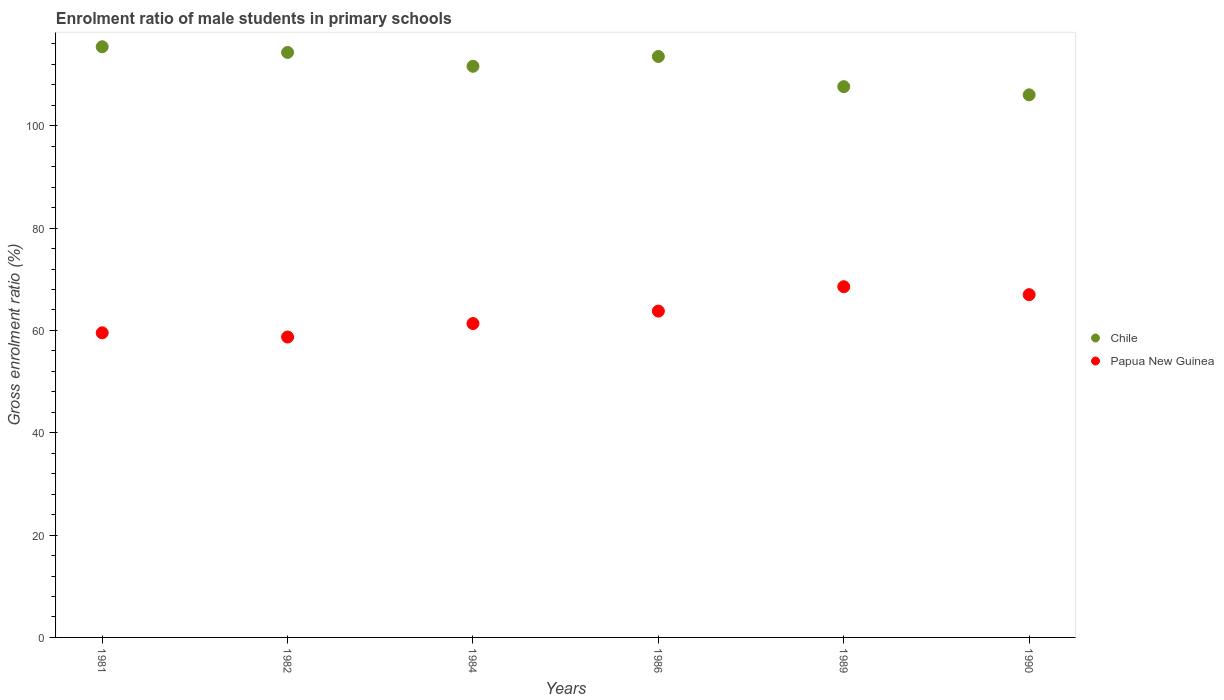What is the enrolment ratio of male students in primary schools in Chile in 1984?
Provide a succinct answer. 111.62. Across all years, what is the maximum enrolment ratio of male students in primary schools in Papua New Guinea?
Provide a short and direct response. 68.54. Across all years, what is the minimum enrolment ratio of male students in primary schools in Chile?
Your answer should be compact. 106.04. What is the total enrolment ratio of male students in primary schools in Chile in the graph?
Your answer should be very brief. 668.6. What is the difference between the enrolment ratio of male students in primary schools in Chile in 1989 and that in 1990?
Keep it short and to the point. 1.6. What is the difference between the enrolment ratio of male students in primary schools in Papua New Guinea in 1981 and the enrolment ratio of male students in primary schools in Chile in 1986?
Provide a short and direct response. -54. What is the average enrolment ratio of male students in primary schools in Papua New Guinea per year?
Keep it short and to the point. 63.15. In the year 1989, what is the difference between the enrolment ratio of male students in primary schools in Chile and enrolment ratio of male students in primary schools in Papua New Guinea?
Keep it short and to the point. 39.1. What is the ratio of the enrolment ratio of male students in primary schools in Papua New Guinea in 1981 to that in 1989?
Your response must be concise. 0.87. Is the enrolment ratio of male students in primary schools in Chile in 1981 less than that in 1989?
Offer a terse response. No. Is the difference between the enrolment ratio of male students in primary schools in Chile in 1984 and 1986 greater than the difference between the enrolment ratio of male students in primary schools in Papua New Guinea in 1984 and 1986?
Your response must be concise. Yes. What is the difference between the highest and the second highest enrolment ratio of male students in primary schools in Papua New Guinea?
Keep it short and to the point. 1.55. What is the difference between the highest and the lowest enrolment ratio of male students in primary schools in Papua New Guinea?
Offer a terse response. 9.83. In how many years, is the enrolment ratio of male students in primary schools in Chile greater than the average enrolment ratio of male students in primary schools in Chile taken over all years?
Keep it short and to the point. 4. Is the sum of the enrolment ratio of male students in primary schools in Chile in 1982 and 1984 greater than the maximum enrolment ratio of male students in primary schools in Papua New Guinea across all years?
Your response must be concise. Yes. Is the enrolment ratio of male students in primary schools in Papua New Guinea strictly less than the enrolment ratio of male students in primary schools in Chile over the years?
Provide a short and direct response. Yes. How many dotlines are there?
Ensure brevity in your answer.  2. What is the difference between two consecutive major ticks on the Y-axis?
Offer a terse response. 20. Are the values on the major ticks of Y-axis written in scientific E-notation?
Your response must be concise. No. Does the graph contain grids?
Ensure brevity in your answer.  No. How many legend labels are there?
Provide a succinct answer. 2. What is the title of the graph?
Your answer should be compact. Enrolment ratio of male students in primary schools. Does "Bahrain" appear as one of the legend labels in the graph?
Offer a terse response. No. What is the label or title of the X-axis?
Provide a succinct answer. Years. What is the Gross enrolment ratio (%) of Chile in 1981?
Your answer should be compact. 115.44. What is the Gross enrolment ratio (%) in Papua New Guinea in 1981?
Make the answer very short. 59.53. What is the Gross enrolment ratio (%) in Chile in 1982?
Offer a very short reply. 114.33. What is the Gross enrolment ratio (%) in Papua New Guinea in 1982?
Provide a short and direct response. 58.71. What is the Gross enrolment ratio (%) of Chile in 1984?
Offer a terse response. 111.62. What is the Gross enrolment ratio (%) in Papua New Guinea in 1984?
Ensure brevity in your answer.  61.34. What is the Gross enrolment ratio (%) of Chile in 1986?
Make the answer very short. 113.53. What is the Gross enrolment ratio (%) in Papua New Guinea in 1986?
Your answer should be very brief. 63.77. What is the Gross enrolment ratio (%) in Chile in 1989?
Offer a very short reply. 107.64. What is the Gross enrolment ratio (%) of Papua New Guinea in 1989?
Provide a short and direct response. 68.54. What is the Gross enrolment ratio (%) of Chile in 1990?
Make the answer very short. 106.04. What is the Gross enrolment ratio (%) in Papua New Guinea in 1990?
Keep it short and to the point. 66.99. Across all years, what is the maximum Gross enrolment ratio (%) of Chile?
Make the answer very short. 115.44. Across all years, what is the maximum Gross enrolment ratio (%) of Papua New Guinea?
Your answer should be very brief. 68.54. Across all years, what is the minimum Gross enrolment ratio (%) in Chile?
Provide a short and direct response. 106.04. Across all years, what is the minimum Gross enrolment ratio (%) of Papua New Guinea?
Make the answer very short. 58.71. What is the total Gross enrolment ratio (%) in Chile in the graph?
Offer a very short reply. 668.6. What is the total Gross enrolment ratio (%) in Papua New Guinea in the graph?
Offer a very short reply. 378.89. What is the difference between the Gross enrolment ratio (%) of Chile in 1981 and that in 1982?
Ensure brevity in your answer.  1.11. What is the difference between the Gross enrolment ratio (%) of Papua New Guinea in 1981 and that in 1982?
Your response must be concise. 0.82. What is the difference between the Gross enrolment ratio (%) in Chile in 1981 and that in 1984?
Provide a succinct answer. 3.82. What is the difference between the Gross enrolment ratio (%) in Papua New Guinea in 1981 and that in 1984?
Ensure brevity in your answer.  -1.81. What is the difference between the Gross enrolment ratio (%) of Chile in 1981 and that in 1986?
Provide a succinct answer. 1.9. What is the difference between the Gross enrolment ratio (%) of Papua New Guinea in 1981 and that in 1986?
Your response must be concise. -4.24. What is the difference between the Gross enrolment ratio (%) of Chile in 1981 and that in 1989?
Make the answer very short. 7.8. What is the difference between the Gross enrolment ratio (%) of Papua New Guinea in 1981 and that in 1989?
Make the answer very short. -9.01. What is the difference between the Gross enrolment ratio (%) in Chile in 1981 and that in 1990?
Keep it short and to the point. 9.39. What is the difference between the Gross enrolment ratio (%) of Papua New Guinea in 1981 and that in 1990?
Make the answer very short. -7.46. What is the difference between the Gross enrolment ratio (%) of Chile in 1982 and that in 1984?
Provide a succinct answer. 2.71. What is the difference between the Gross enrolment ratio (%) in Papua New Guinea in 1982 and that in 1984?
Keep it short and to the point. -2.63. What is the difference between the Gross enrolment ratio (%) in Chile in 1982 and that in 1986?
Provide a short and direct response. 0.79. What is the difference between the Gross enrolment ratio (%) of Papua New Guinea in 1982 and that in 1986?
Provide a succinct answer. -5.06. What is the difference between the Gross enrolment ratio (%) in Chile in 1982 and that in 1989?
Your answer should be compact. 6.69. What is the difference between the Gross enrolment ratio (%) of Papua New Guinea in 1982 and that in 1989?
Provide a succinct answer. -9.83. What is the difference between the Gross enrolment ratio (%) of Chile in 1982 and that in 1990?
Offer a very short reply. 8.29. What is the difference between the Gross enrolment ratio (%) in Papua New Guinea in 1982 and that in 1990?
Ensure brevity in your answer.  -8.28. What is the difference between the Gross enrolment ratio (%) of Chile in 1984 and that in 1986?
Provide a succinct answer. -1.91. What is the difference between the Gross enrolment ratio (%) of Papua New Guinea in 1984 and that in 1986?
Your answer should be compact. -2.43. What is the difference between the Gross enrolment ratio (%) of Chile in 1984 and that in 1989?
Offer a terse response. 3.98. What is the difference between the Gross enrolment ratio (%) of Papua New Guinea in 1984 and that in 1989?
Keep it short and to the point. -7.2. What is the difference between the Gross enrolment ratio (%) in Chile in 1984 and that in 1990?
Offer a terse response. 5.58. What is the difference between the Gross enrolment ratio (%) in Papua New Guinea in 1984 and that in 1990?
Give a very brief answer. -5.65. What is the difference between the Gross enrolment ratio (%) of Chile in 1986 and that in 1989?
Provide a short and direct response. 5.9. What is the difference between the Gross enrolment ratio (%) of Papua New Guinea in 1986 and that in 1989?
Give a very brief answer. -4.77. What is the difference between the Gross enrolment ratio (%) of Chile in 1986 and that in 1990?
Provide a succinct answer. 7.49. What is the difference between the Gross enrolment ratio (%) in Papua New Guinea in 1986 and that in 1990?
Offer a terse response. -3.21. What is the difference between the Gross enrolment ratio (%) in Chile in 1989 and that in 1990?
Offer a very short reply. 1.6. What is the difference between the Gross enrolment ratio (%) of Papua New Guinea in 1989 and that in 1990?
Provide a short and direct response. 1.55. What is the difference between the Gross enrolment ratio (%) of Chile in 1981 and the Gross enrolment ratio (%) of Papua New Guinea in 1982?
Your answer should be compact. 56.72. What is the difference between the Gross enrolment ratio (%) in Chile in 1981 and the Gross enrolment ratio (%) in Papua New Guinea in 1984?
Offer a very short reply. 54.09. What is the difference between the Gross enrolment ratio (%) in Chile in 1981 and the Gross enrolment ratio (%) in Papua New Guinea in 1986?
Make the answer very short. 51.66. What is the difference between the Gross enrolment ratio (%) in Chile in 1981 and the Gross enrolment ratio (%) in Papua New Guinea in 1989?
Keep it short and to the point. 46.89. What is the difference between the Gross enrolment ratio (%) in Chile in 1981 and the Gross enrolment ratio (%) in Papua New Guinea in 1990?
Make the answer very short. 48.45. What is the difference between the Gross enrolment ratio (%) in Chile in 1982 and the Gross enrolment ratio (%) in Papua New Guinea in 1984?
Your response must be concise. 52.98. What is the difference between the Gross enrolment ratio (%) in Chile in 1982 and the Gross enrolment ratio (%) in Papua New Guinea in 1986?
Provide a short and direct response. 50.55. What is the difference between the Gross enrolment ratio (%) of Chile in 1982 and the Gross enrolment ratio (%) of Papua New Guinea in 1989?
Your response must be concise. 45.79. What is the difference between the Gross enrolment ratio (%) in Chile in 1982 and the Gross enrolment ratio (%) in Papua New Guinea in 1990?
Provide a short and direct response. 47.34. What is the difference between the Gross enrolment ratio (%) in Chile in 1984 and the Gross enrolment ratio (%) in Papua New Guinea in 1986?
Your response must be concise. 47.85. What is the difference between the Gross enrolment ratio (%) of Chile in 1984 and the Gross enrolment ratio (%) of Papua New Guinea in 1989?
Offer a very short reply. 43.08. What is the difference between the Gross enrolment ratio (%) in Chile in 1984 and the Gross enrolment ratio (%) in Papua New Guinea in 1990?
Provide a short and direct response. 44.63. What is the difference between the Gross enrolment ratio (%) in Chile in 1986 and the Gross enrolment ratio (%) in Papua New Guinea in 1989?
Your response must be concise. 44.99. What is the difference between the Gross enrolment ratio (%) in Chile in 1986 and the Gross enrolment ratio (%) in Papua New Guinea in 1990?
Offer a terse response. 46.55. What is the difference between the Gross enrolment ratio (%) in Chile in 1989 and the Gross enrolment ratio (%) in Papua New Guinea in 1990?
Your answer should be compact. 40.65. What is the average Gross enrolment ratio (%) in Chile per year?
Your response must be concise. 111.43. What is the average Gross enrolment ratio (%) of Papua New Guinea per year?
Make the answer very short. 63.15. In the year 1981, what is the difference between the Gross enrolment ratio (%) of Chile and Gross enrolment ratio (%) of Papua New Guinea?
Your answer should be compact. 55.91. In the year 1982, what is the difference between the Gross enrolment ratio (%) of Chile and Gross enrolment ratio (%) of Papua New Guinea?
Offer a terse response. 55.61. In the year 1984, what is the difference between the Gross enrolment ratio (%) in Chile and Gross enrolment ratio (%) in Papua New Guinea?
Keep it short and to the point. 50.28. In the year 1986, what is the difference between the Gross enrolment ratio (%) of Chile and Gross enrolment ratio (%) of Papua New Guinea?
Make the answer very short. 49.76. In the year 1989, what is the difference between the Gross enrolment ratio (%) of Chile and Gross enrolment ratio (%) of Papua New Guinea?
Make the answer very short. 39.1. In the year 1990, what is the difference between the Gross enrolment ratio (%) in Chile and Gross enrolment ratio (%) in Papua New Guinea?
Provide a short and direct response. 39.05. What is the ratio of the Gross enrolment ratio (%) in Chile in 1981 to that in 1982?
Your response must be concise. 1.01. What is the ratio of the Gross enrolment ratio (%) in Papua New Guinea in 1981 to that in 1982?
Offer a very short reply. 1.01. What is the ratio of the Gross enrolment ratio (%) of Chile in 1981 to that in 1984?
Make the answer very short. 1.03. What is the ratio of the Gross enrolment ratio (%) of Papua New Guinea in 1981 to that in 1984?
Offer a terse response. 0.97. What is the ratio of the Gross enrolment ratio (%) of Chile in 1981 to that in 1986?
Keep it short and to the point. 1.02. What is the ratio of the Gross enrolment ratio (%) of Papua New Guinea in 1981 to that in 1986?
Provide a succinct answer. 0.93. What is the ratio of the Gross enrolment ratio (%) of Chile in 1981 to that in 1989?
Provide a short and direct response. 1.07. What is the ratio of the Gross enrolment ratio (%) of Papua New Guinea in 1981 to that in 1989?
Your answer should be compact. 0.87. What is the ratio of the Gross enrolment ratio (%) of Chile in 1981 to that in 1990?
Offer a terse response. 1.09. What is the ratio of the Gross enrolment ratio (%) in Papua New Guinea in 1981 to that in 1990?
Ensure brevity in your answer.  0.89. What is the ratio of the Gross enrolment ratio (%) in Chile in 1982 to that in 1984?
Make the answer very short. 1.02. What is the ratio of the Gross enrolment ratio (%) of Papua New Guinea in 1982 to that in 1984?
Give a very brief answer. 0.96. What is the ratio of the Gross enrolment ratio (%) of Chile in 1982 to that in 1986?
Keep it short and to the point. 1.01. What is the ratio of the Gross enrolment ratio (%) in Papua New Guinea in 1982 to that in 1986?
Give a very brief answer. 0.92. What is the ratio of the Gross enrolment ratio (%) in Chile in 1982 to that in 1989?
Your answer should be very brief. 1.06. What is the ratio of the Gross enrolment ratio (%) in Papua New Guinea in 1982 to that in 1989?
Your answer should be compact. 0.86. What is the ratio of the Gross enrolment ratio (%) of Chile in 1982 to that in 1990?
Keep it short and to the point. 1.08. What is the ratio of the Gross enrolment ratio (%) of Papua New Guinea in 1982 to that in 1990?
Give a very brief answer. 0.88. What is the ratio of the Gross enrolment ratio (%) of Chile in 1984 to that in 1986?
Your answer should be very brief. 0.98. What is the ratio of the Gross enrolment ratio (%) in Papua New Guinea in 1984 to that in 1986?
Keep it short and to the point. 0.96. What is the ratio of the Gross enrolment ratio (%) in Papua New Guinea in 1984 to that in 1989?
Offer a very short reply. 0.9. What is the ratio of the Gross enrolment ratio (%) in Chile in 1984 to that in 1990?
Make the answer very short. 1.05. What is the ratio of the Gross enrolment ratio (%) in Papua New Guinea in 1984 to that in 1990?
Your answer should be very brief. 0.92. What is the ratio of the Gross enrolment ratio (%) of Chile in 1986 to that in 1989?
Give a very brief answer. 1.05. What is the ratio of the Gross enrolment ratio (%) in Papua New Guinea in 1986 to that in 1989?
Offer a terse response. 0.93. What is the ratio of the Gross enrolment ratio (%) in Chile in 1986 to that in 1990?
Provide a short and direct response. 1.07. What is the ratio of the Gross enrolment ratio (%) of Chile in 1989 to that in 1990?
Your response must be concise. 1.02. What is the ratio of the Gross enrolment ratio (%) of Papua New Guinea in 1989 to that in 1990?
Provide a succinct answer. 1.02. What is the difference between the highest and the second highest Gross enrolment ratio (%) of Chile?
Offer a very short reply. 1.11. What is the difference between the highest and the second highest Gross enrolment ratio (%) in Papua New Guinea?
Make the answer very short. 1.55. What is the difference between the highest and the lowest Gross enrolment ratio (%) of Chile?
Offer a terse response. 9.39. What is the difference between the highest and the lowest Gross enrolment ratio (%) in Papua New Guinea?
Offer a terse response. 9.83. 